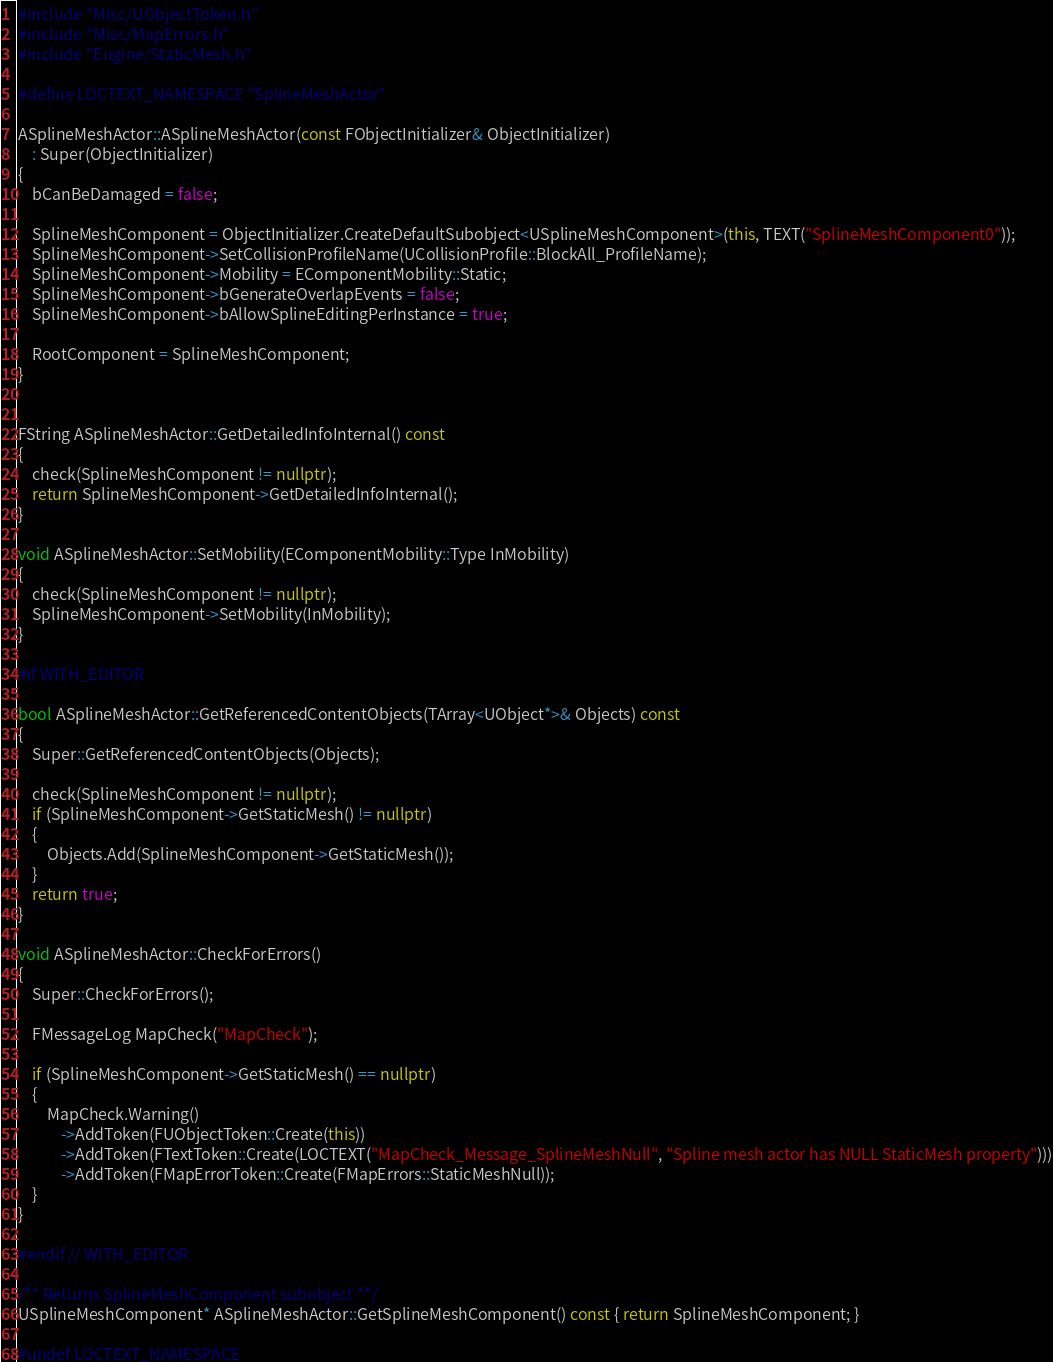Convert code to text. <code><loc_0><loc_0><loc_500><loc_500><_C++_>#include "Misc/UObjectToken.h"
#include "Misc/MapErrors.h"
#include "Engine/StaticMesh.h"

#define LOCTEXT_NAMESPACE "SplineMeshActor"

ASplineMeshActor::ASplineMeshActor(const FObjectInitializer& ObjectInitializer)
	: Super(ObjectInitializer)
{
	bCanBeDamaged = false;

	SplineMeshComponent = ObjectInitializer.CreateDefaultSubobject<USplineMeshComponent>(this, TEXT("SplineMeshComponent0"));
	SplineMeshComponent->SetCollisionProfileName(UCollisionProfile::BlockAll_ProfileName);
	SplineMeshComponent->Mobility = EComponentMobility::Static;
	SplineMeshComponent->bGenerateOverlapEvents = false;
	SplineMeshComponent->bAllowSplineEditingPerInstance = true;

	RootComponent = SplineMeshComponent;
}


FString ASplineMeshActor::GetDetailedInfoInternal() const
{
	check(SplineMeshComponent != nullptr);
	return SplineMeshComponent->GetDetailedInfoInternal();
}

void ASplineMeshActor::SetMobility(EComponentMobility::Type InMobility)
{
	check(SplineMeshComponent != nullptr);
	SplineMeshComponent->SetMobility(InMobility);
}

#if WITH_EDITOR

bool ASplineMeshActor::GetReferencedContentObjects(TArray<UObject*>& Objects) const
{
	Super::GetReferencedContentObjects(Objects);

	check(SplineMeshComponent != nullptr);
	if (SplineMeshComponent->GetStaticMesh() != nullptr)
	{
		Objects.Add(SplineMeshComponent->GetStaticMesh());
	}
	return true;
}

void ASplineMeshActor::CheckForErrors()
{
	Super::CheckForErrors();

	FMessageLog MapCheck("MapCheck");

	if (SplineMeshComponent->GetStaticMesh() == nullptr)
	{
		MapCheck.Warning()
			->AddToken(FUObjectToken::Create(this))
			->AddToken(FTextToken::Create(LOCTEXT("MapCheck_Message_SplineMeshNull", "Spline mesh actor has NULL StaticMesh property")))
			->AddToken(FMapErrorToken::Create(FMapErrors::StaticMeshNull));
	}
}

#endif // WITH_EDITOR

/** Returns SplineMeshComponent subobject **/
USplineMeshComponent* ASplineMeshActor::GetSplineMeshComponent() const { return SplineMeshComponent; }

#undef LOCTEXT_NAMESPACE
</code> 